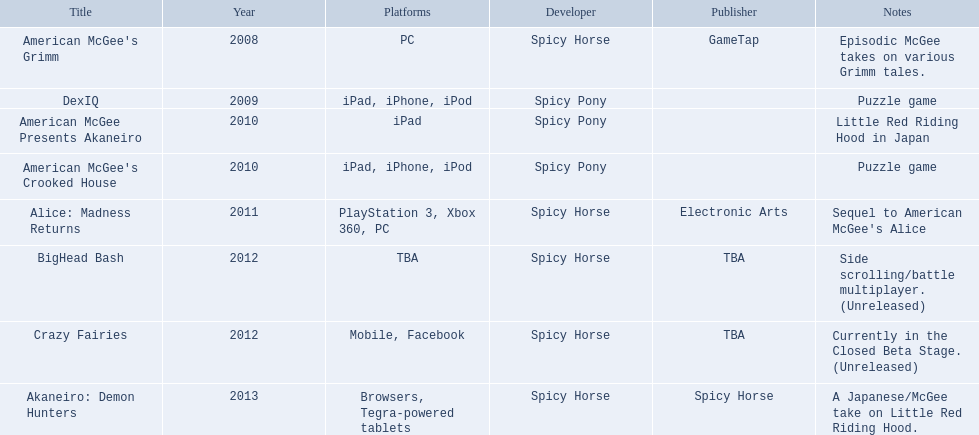What spicy horse titles are listed? American McGee's Grimm, DexIQ, American McGee Presents Akaneiro, American McGee's Crooked House, Alice: Madness Returns, BigHead Bash, Crazy Fairies, Akaneiro: Demon Hunters. Which of these can be used on ipad? DexIQ, American McGee Presents Akaneiro, American McGee's Crooked House. Which left cannot also be used on iphone or ipod? American McGee Presents Akaneiro. What are the entire collection of titles? American McGee's Grimm, DexIQ, American McGee Presents Akaneiro, American McGee's Crooked House, Alice: Madness Returns, BigHead Bash, Crazy Fairies, Akaneiro: Demon Hunters. Who produced each title? GameTap, , , , Electronic Arts, TBA, TBA, Spicy Horse. Which game was published by electronic arts? Alice: Madness Returns. 